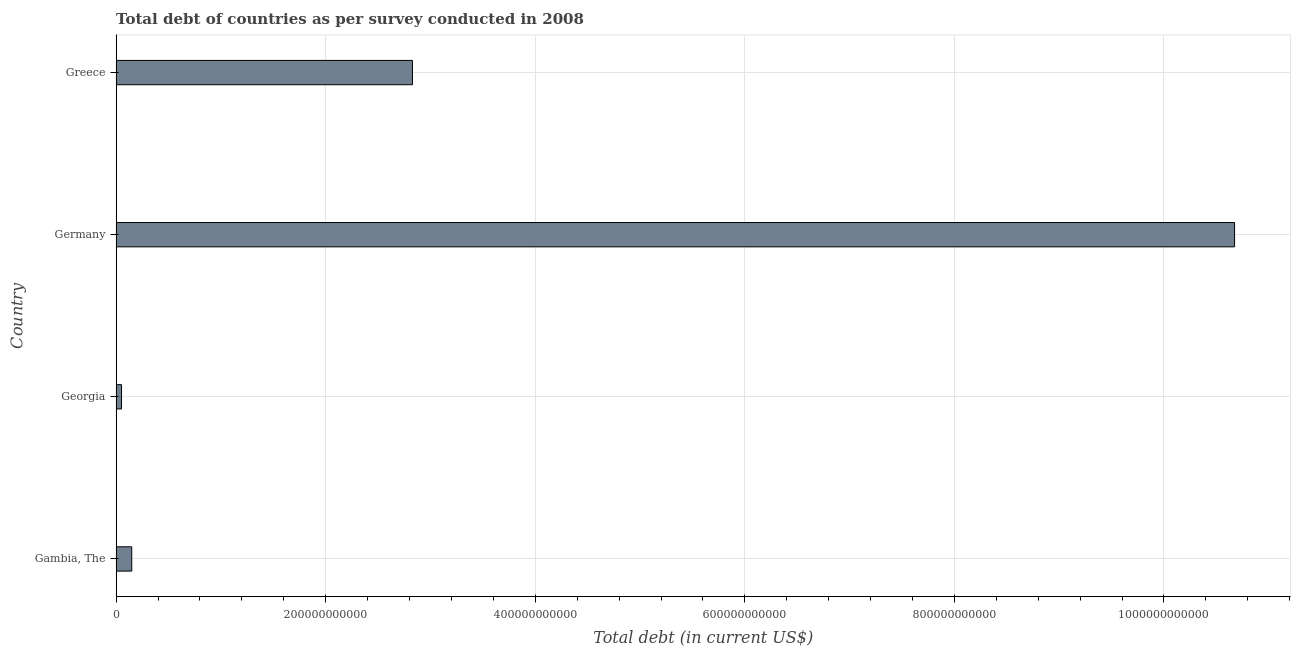Does the graph contain grids?
Your answer should be very brief. Yes. What is the title of the graph?
Provide a succinct answer. Total debt of countries as per survey conducted in 2008. What is the label or title of the X-axis?
Provide a short and direct response. Total debt (in current US$). What is the total debt in Georgia?
Offer a terse response. 5.15e+09. Across all countries, what is the maximum total debt?
Your response must be concise. 1.07e+12. Across all countries, what is the minimum total debt?
Give a very brief answer. 5.15e+09. In which country was the total debt minimum?
Ensure brevity in your answer.  Georgia. What is the sum of the total debt?
Provide a short and direct response. 1.37e+12. What is the difference between the total debt in Gambia, The and Germany?
Offer a very short reply. -1.05e+12. What is the average total debt per country?
Keep it short and to the point. 3.43e+11. What is the median total debt?
Your answer should be very brief. 1.49e+11. What is the ratio of the total debt in Germany to that in Greece?
Offer a terse response. 3.77. Is the total debt in Germany less than that in Greece?
Provide a succinct answer. No. What is the difference between the highest and the second highest total debt?
Ensure brevity in your answer.  7.85e+11. Is the sum of the total debt in Gambia, The and Greece greater than the maximum total debt across all countries?
Keep it short and to the point. No. What is the difference between the highest and the lowest total debt?
Offer a terse response. 1.06e+12. Are all the bars in the graph horizontal?
Your response must be concise. Yes. How many countries are there in the graph?
Your answer should be compact. 4. What is the difference between two consecutive major ticks on the X-axis?
Keep it short and to the point. 2.00e+11. What is the Total debt (in current US$) in Gambia, The?
Give a very brief answer. 1.49e+1. What is the Total debt (in current US$) in Georgia?
Provide a short and direct response. 5.15e+09. What is the Total debt (in current US$) of Germany?
Your answer should be compact. 1.07e+12. What is the Total debt (in current US$) in Greece?
Give a very brief answer. 2.83e+11. What is the difference between the Total debt (in current US$) in Gambia, The and Georgia?
Offer a very short reply. 9.73e+09. What is the difference between the Total debt (in current US$) in Gambia, The and Germany?
Provide a short and direct response. -1.05e+12. What is the difference between the Total debt (in current US$) in Gambia, The and Greece?
Your answer should be very brief. -2.68e+11. What is the difference between the Total debt (in current US$) in Georgia and Germany?
Keep it short and to the point. -1.06e+12. What is the difference between the Total debt (in current US$) in Georgia and Greece?
Offer a terse response. -2.78e+11. What is the difference between the Total debt (in current US$) in Germany and Greece?
Your answer should be very brief. 7.85e+11. What is the ratio of the Total debt (in current US$) in Gambia, The to that in Georgia?
Provide a succinct answer. 2.89. What is the ratio of the Total debt (in current US$) in Gambia, The to that in Germany?
Offer a very short reply. 0.01. What is the ratio of the Total debt (in current US$) in Gambia, The to that in Greece?
Offer a terse response. 0.05. What is the ratio of the Total debt (in current US$) in Georgia to that in Germany?
Offer a very short reply. 0.01. What is the ratio of the Total debt (in current US$) in Georgia to that in Greece?
Ensure brevity in your answer.  0.02. What is the ratio of the Total debt (in current US$) in Germany to that in Greece?
Your answer should be compact. 3.77. 